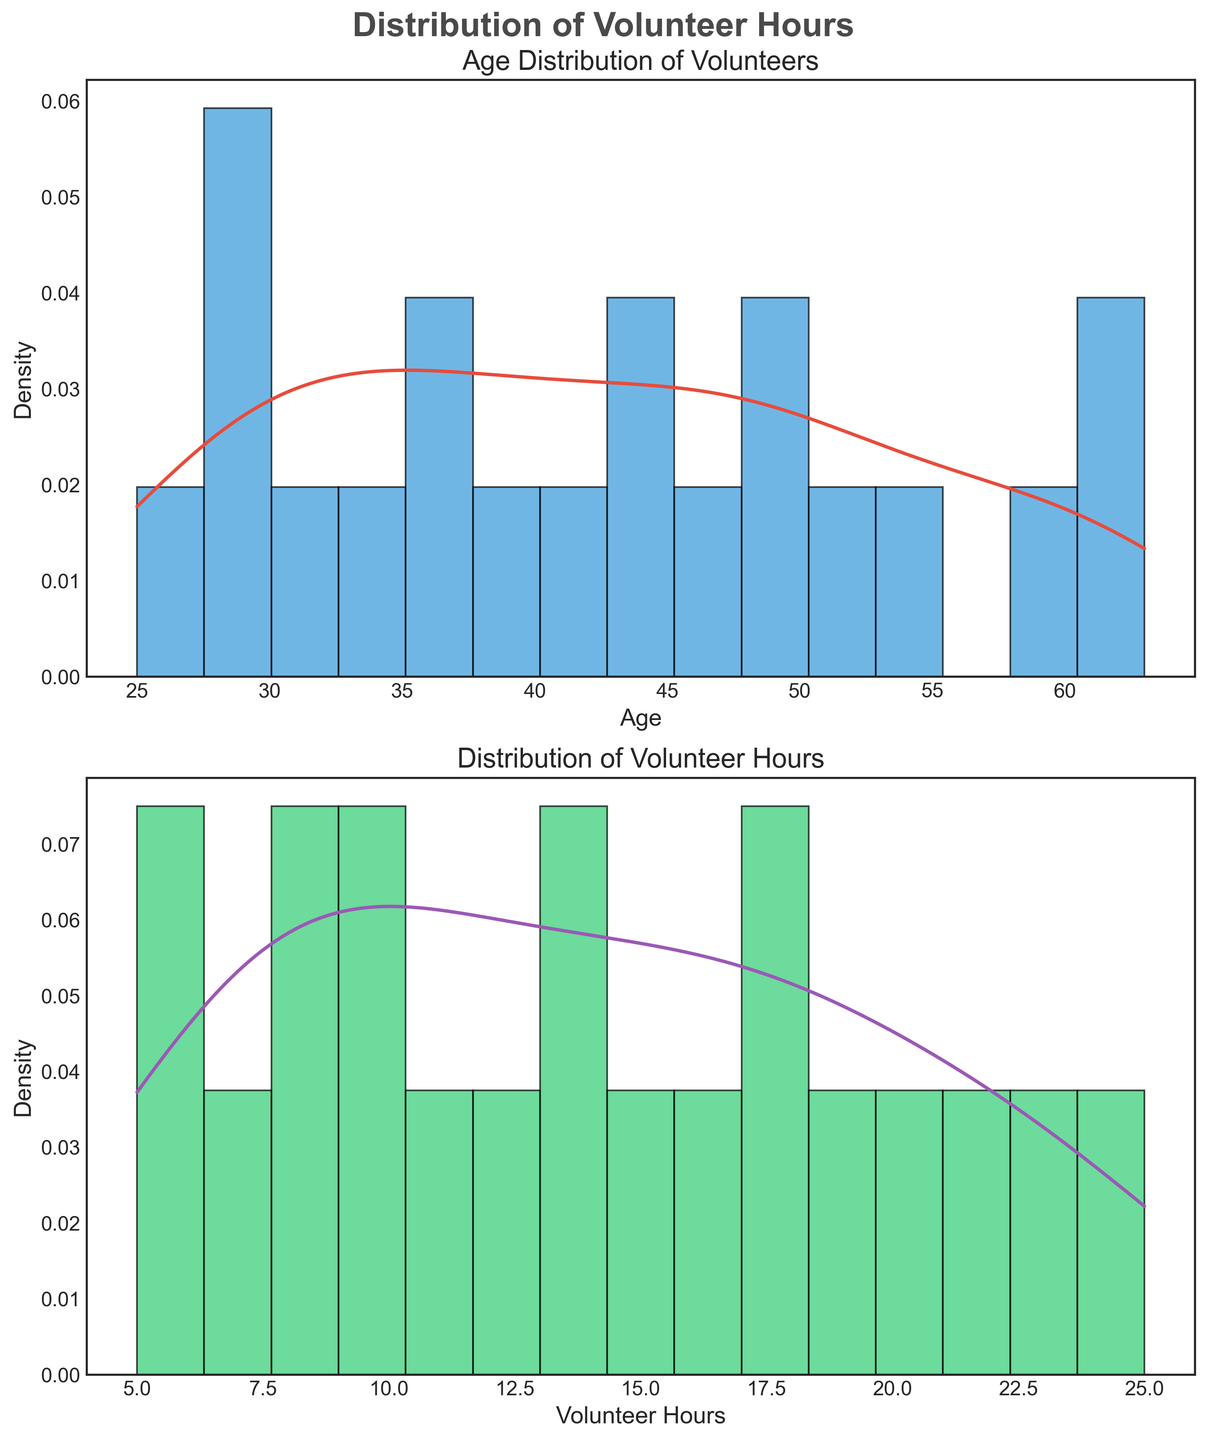What are the titles of the two subplots? The titles of the two subplots can be read directly from the figure. The first subplot's title is located at the top of the first plot, and the second subplot's title is located at the top of the second plot.
Answer: "Age Distribution of Volunteers" and "Distribution of Volunteer Hours" What is the range of ages shown in the age distribution? The range of the age distribution can be determined by looking at the x-axis of the first subplot. The minimum value is the leftmost value, and the maximum value is the rightmost value on the axis.
Answer: 25 to 63 Which age group shows higher density, around 30 or around 60? By comparing the heights of the densest points on the KDE curve around these two age values, we can discern which group shows higher density.
Answer: Around 30 What does the red line in the age distribution subplot represent? The red line on the first subplot is a KDE (Kernel Density Estimate) plot, which shows the estimated probability density of age distribution among volunteers.
Answer: KDE of age What is the most common range of volunteer hours based on the second subplot? By looking at the height of the histogram bars in the second subplot, the range with the highest bar indicates the most common range of volunteer hours.
Answer: Around 20-25 hours How do the distributions of ages and volunteer hours compare in shape? To compare the shapes, we observe whether the distributions are symmetrical, skewed, or show multiple peaks. Both density plots show this information for their respective variables. Detailed comparison reveals whether both distributions share similarities.
Answer: Both are similar in shape, each with a peak and a taper Which density plot appears more spread out, age or volunteer hours? This can be visualized by observing the x-axis range and the spread of the KDE curves in both subplots. The one with a wider spread indicates more variation.
Answer: Age What is the peak density value of volunteer hours? By observing the highest point on the KDE curve in the second subplot, we can estimate the peak density value.
Answer: Around 0.1 Are there any age or volunteer hour categories that show no density? If so, which ones? By looking for gaps in the histograms and KDE plots where there are no bins or peaks, one can identify any age or hour ranges with zero density.
Answer: No gaps Can you identify an age range with relatively low volunteer hours from the plot? By cross-referencing the age ranges on the first plot with the volunteer hours distribution on the second, one can look for overlap or lack thereof between low hours and specific age ranges.
Answer: Ages around mid-20s (e.g., 25-30) 